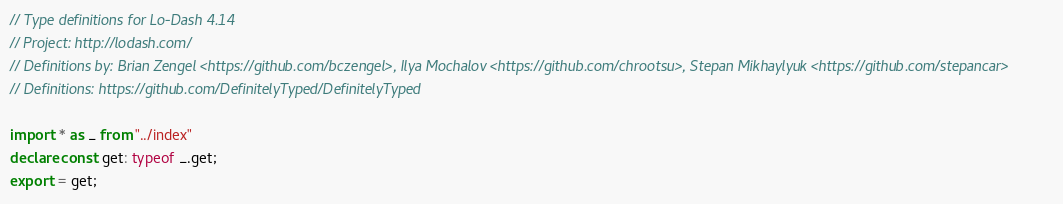Convert code to text. <code><loc_0><loc_0><loc_500><loc_500><_TypeScript_>// Type definitions for Lo-Dash 4.14
// Project: http://lodash.com/
// Definitions by: Brian Zengel <https://github.com/bczengel>, Ilya Mochalov <https://github.com/chrootsu>, Stepan Mikhaylyuk <https://github.com/stepancar>
// Definitions: https://github.com/DefinitelyTyped/DefinitelyTyped

import * as _ from "../index"
declare const get: typeof _.get;
export = get;
</code> 